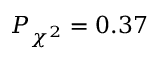Convert formula to latex. <formula><loc_0><loc_0><loc_500><loc_500>P _ { \chi ^ { 2 } } = 0 . 3 7</formula> 